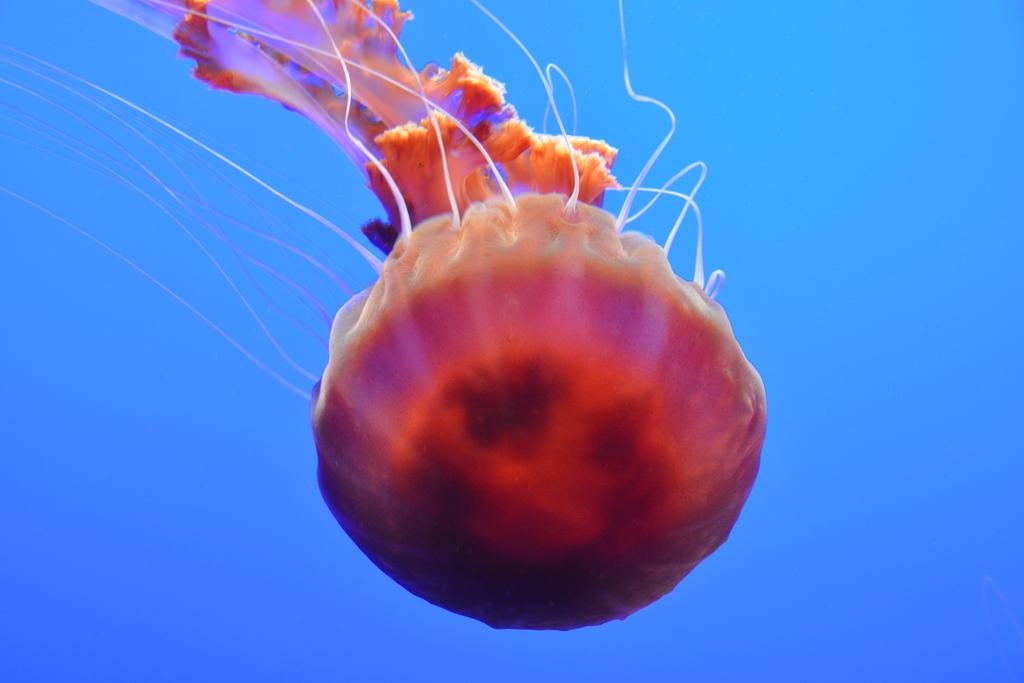What type of marine animals are in the image? There are jellyfish in the image. What color is the background of the image? The background of the image is blue. What book is the jellyfish reading in the image? There is no book or reading activity present in the image, as jellyfish do not have the ability to read. 